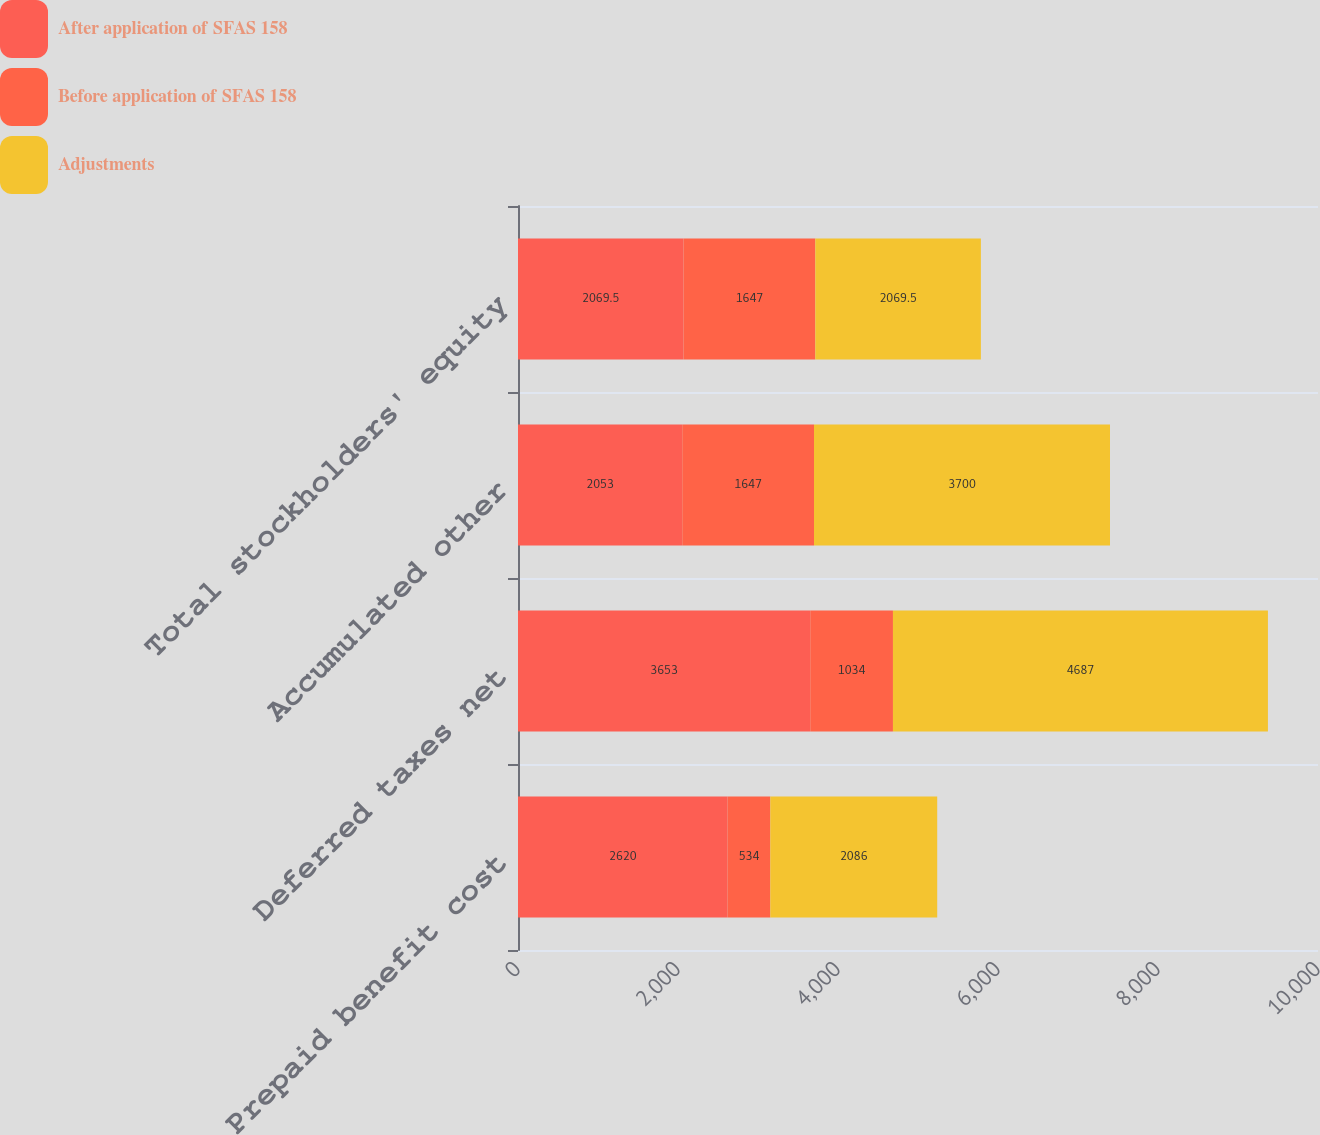Convert chart to OTSL. <chart><loc_0><loc_0><loc_500><loc_500><stacked_bar_chart><ecel><fcel>Prepaid benefit cost<fcel>Deferred taxes net<fcel>Accumulated other<fcel>Total stockholders' equity<nl><fcel>After application of SFAS 158<fcel>2620<fcel>3653<fcel>2053<fcel>2069.5<nl><fcel>Before application of SFAS 158<fcel>534<fcel>1034<fcel>1647<fcel>1647<nl><fcel>Adjustments<fcel>2086<fcel>4687<fcel>3700<fcel>2069.5<nl></chart> 